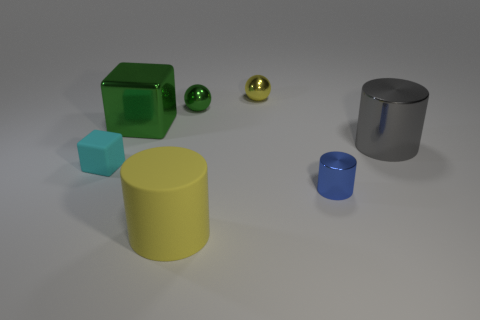There is a large cylinder that is the same material as the cyan object; what color is it?
Keep it short and to the point. Yellow. The large green metal object is what shape?
Your response must be concise. Cube. How many big blocks have the same color as the big metal cylinder?
Ensure brevity in your answer.  0. There is a blue shiny thing that is the same size as the cyan cube; what shape is it?
Provide a succinct answer. Cylinder. Are there any other rubber things that have the same size as the gray object?
Make the answer very short. Yes. There is a blue thing that is the same size as the cyan object; what is it made of?
Give a very brief answer. Metal. How big is the green metal thing on the right side of the large object in front of the cyan object?
Keep it short and to the point. Small. There is a block that is behind the gray metal object; does it have the same size as the blue cylinder?
Make the answer very short. No. Are there more tiny cylinders that are right of the blue shiny cylinder than big blocks that are to the left of the big yellow rubber object?
Your answer should be very brief. No. What shape is the thing that is both to the right of the cyan block and left of the yellow rubber thing?
Your answer should be compact. Cube. 